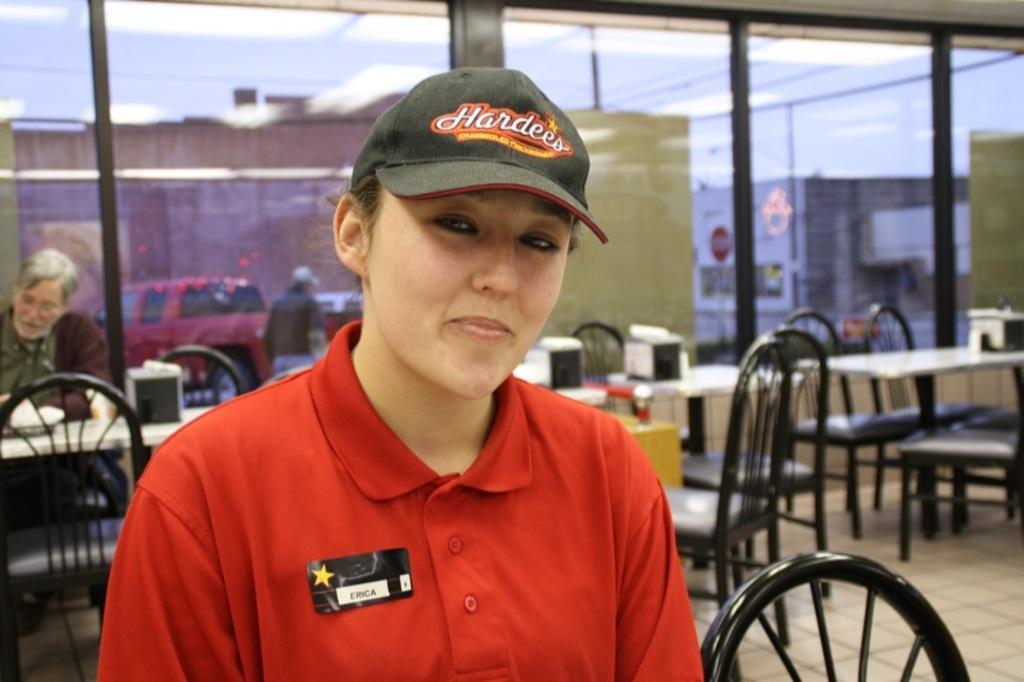Can you describe this image briefly? This picture is clicked in a hotel. Woman in red t-shirt is wearing cap and she is smiling. Behind her, we see chairs and tables and man is sitting on a chair. Behind him, we see windows from which we can see man walking on the road and also vehicles moving on the road and begin the behind that vehicles we see buildings. 